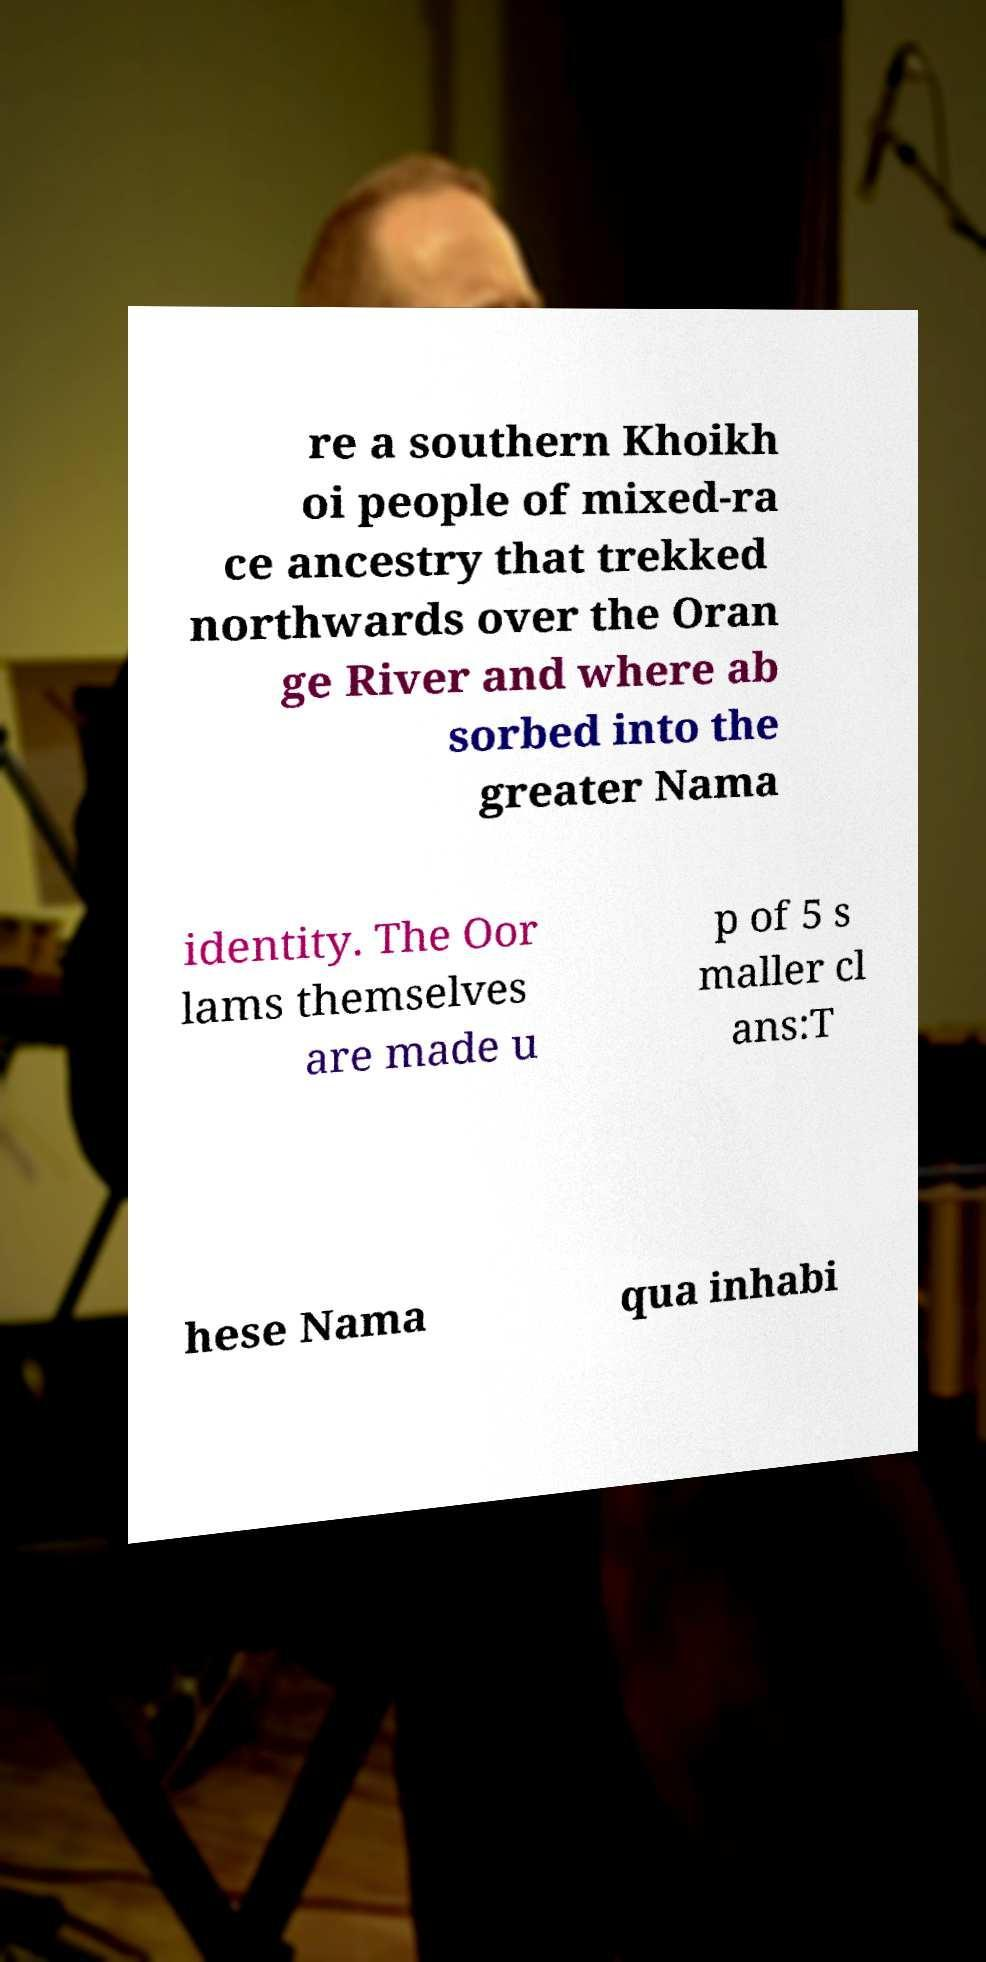Please read and relay the text visible in this image. What does it say? re a southern Khoikh oi people of mixed-ra ce ancestry that trekked northwards over the Oran ge River and where ab sorbed into the greater Nama identity. The Oor lams themselves are made u p of 5 s maller cl ans:T hese Nama qua inhabi 